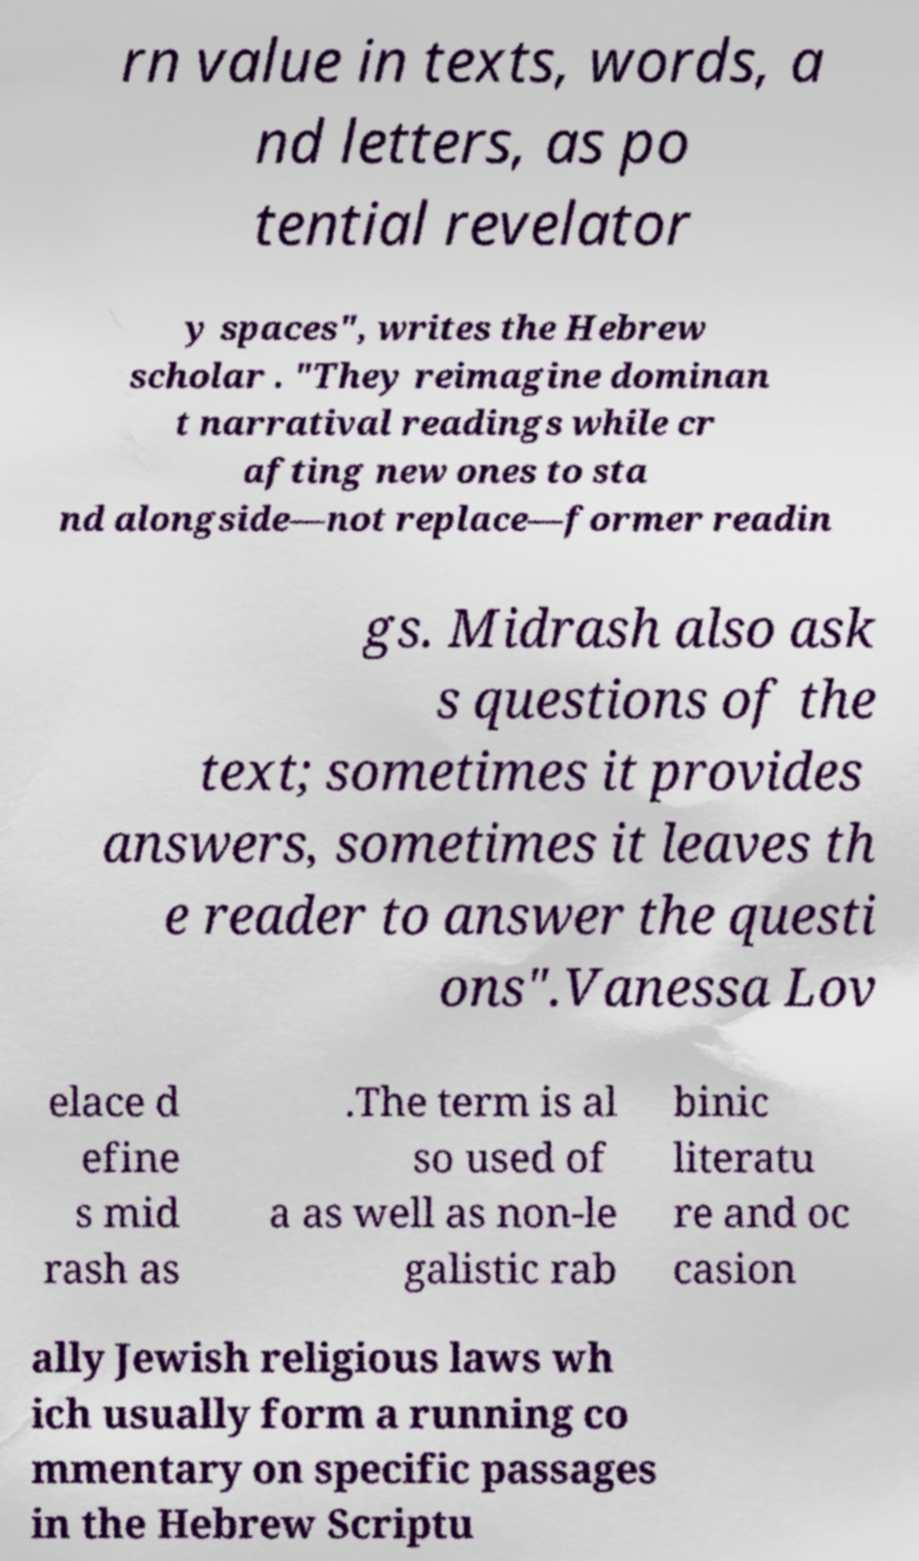Please identify and transcribe the text found in this image. rn value in texts, words, a nd letters, as po tential revelator y spaces", writes the Hebrew scholar . "They reimagine dominan t narratival readings while cr afting new ones to sta nd alongside—not replace—former readin gs. Midrash also ask s questions of the text; sometimes it provides answers, sometimes it leaves th e reader to answer the questi ons".Vanessa Lov elace d efine s mid rash as .The term is al so used of a as well as non-le galistic rab binic literatu re and oc casion ally Jewish religious laws wh ich usually form a running co mmentary on specific passages in the Hebrew Scriptu 